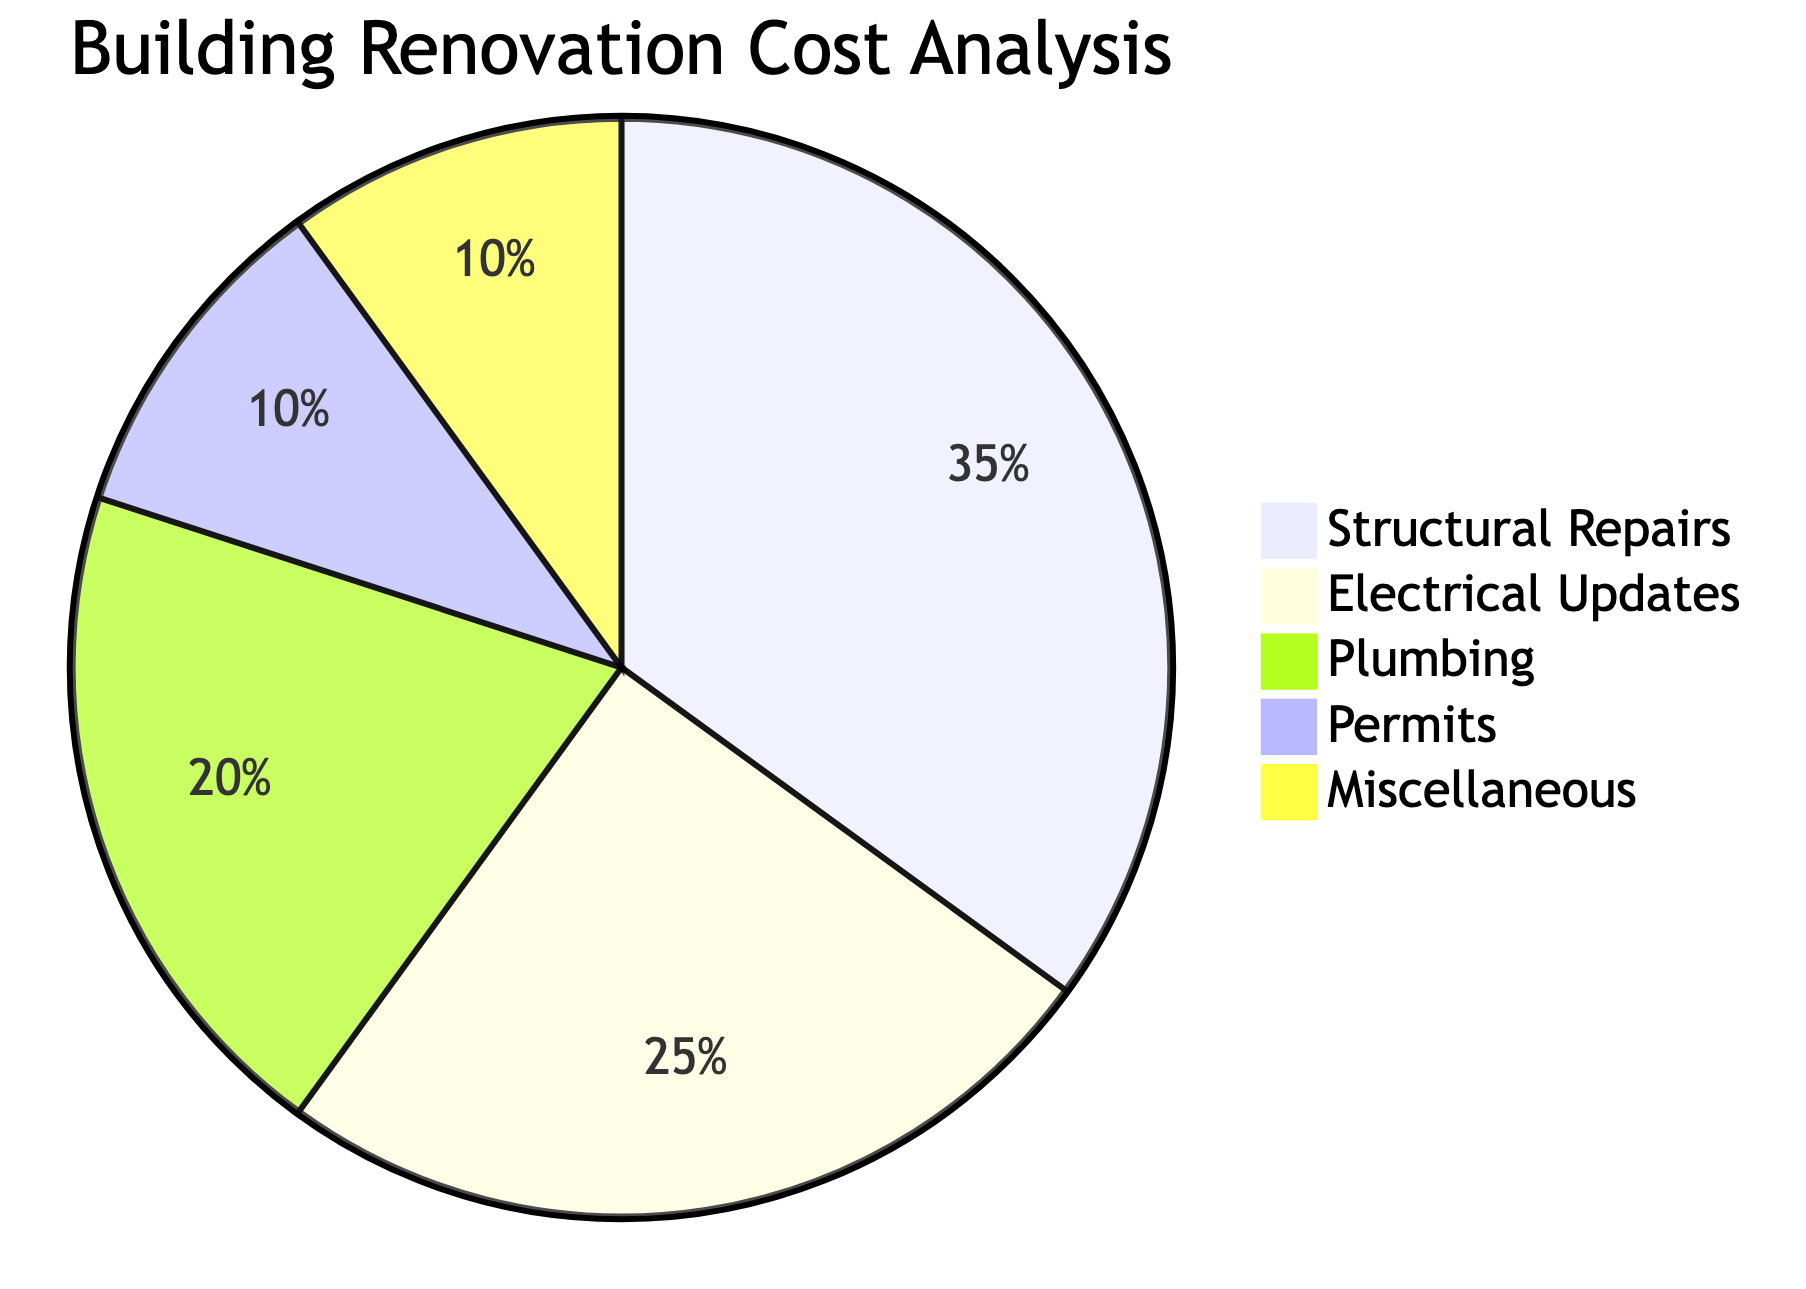What is the largest slice of the pie chart? The pie chart shows multiple slices representing different renovation costs. To find the largest slice, we look for the category with the highest percentage. In this case, "Structural Repairs" has the largest allocation at 35%.
Answer: Structural Repairs How much is allocated for Electrical Updates? By looking at the pie chart's slices, we can see the specific percentage allocated for "Electrical Updates" which is clearly marked at 25%.
Answer: 25 What percentage is allocated for Permits? To determine the percentage for "Permits," we need to find the corresponding slice in the pie chart. The slice for "Permits" is shown to be 10%.
Answer: 10 Which two categories have equal costs? To identify categories with equal costs, we check the slices for similar percentages. In this case, both "Miscellaneous" and "Permits" are noted to have the same allocation of 10%.
Answer: Miscellaneous and Permits What is the combined percentage for Plumbing and Electrical Updates? To find the combined percentage, we need to add the allocations for "Plumbing" (20%) and "Electrical Updates" (25%). Adding these two values results in a total of 45%.
Answer: 45 What is the percentage difference between Structural Repairs and Plumbing? We find the percentages for both categories: "Structural Repairs" at 35% and "Plumbing" at 20%. The difference is calculated by subtracting the percentage of Plumbing from Structural Repairs, which gives us 15%.
Answer: 15 How many categories are shown in the pie chart? By counting the distinct slices within the pie chart, we find there are five categories: Structural Repairs, Electrical Updates, Plumbing, Permits, and Miscellaneous.
Answer: 5 What is the total percentage represented in the pie chart? A pie chart represents a whole (100%), thus the total percentage in this chart is inherently 100%.
Answer: 100 